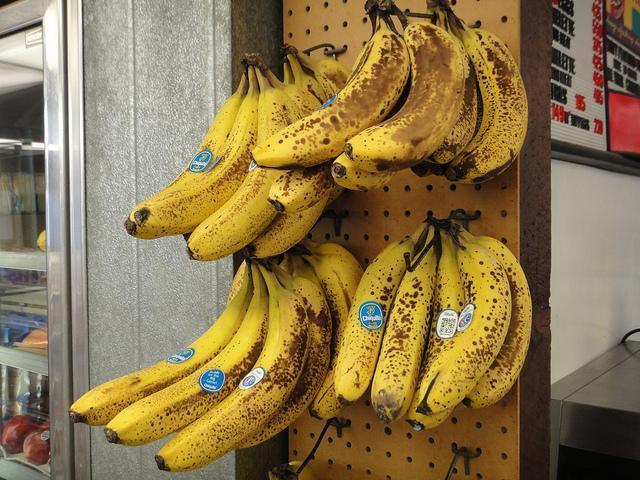How many stacks of bananas are in the photo?
Give a very brief answer. 4. How many bananas are in the bunch?
Give a very brief answer. 6. How many bananas are in the picture?
Give a very brief answer. 10. How many cars are facing north in the picture?
Give a very brief answer. 0. 